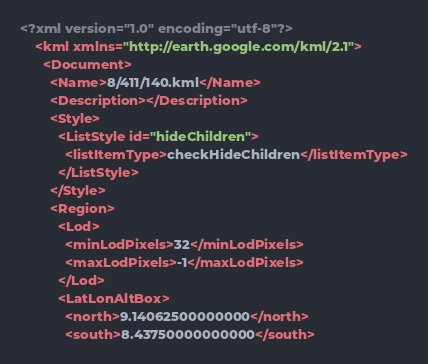<code> <loc_0><loc_0><loc_500><loc_500><_XML_><?xml version="1.0" encoding="utf-8"?>
	<kml xmlns="http://earth.google.com/kml/2.1">
	  <Document>
	    <Name>8/411/140.kml</Name>
	    <Description></Description>
	    <Style>
	      <ListStyle id="hideChildren">
	        <listItemType>checkHideChildren</listItemType>
	      </ListStyle>
	    </Style>
	    <Region>
	      <Lod>
	        <minLodPixels>32</minLodPixels>
	        <maxLodPixels>-1</maxLodPixels>
	      </Lod>
	      <LatLonAltBox>
	        <north>9.14062500000000</north>
	        <south>8.43750000000000</south></code> 